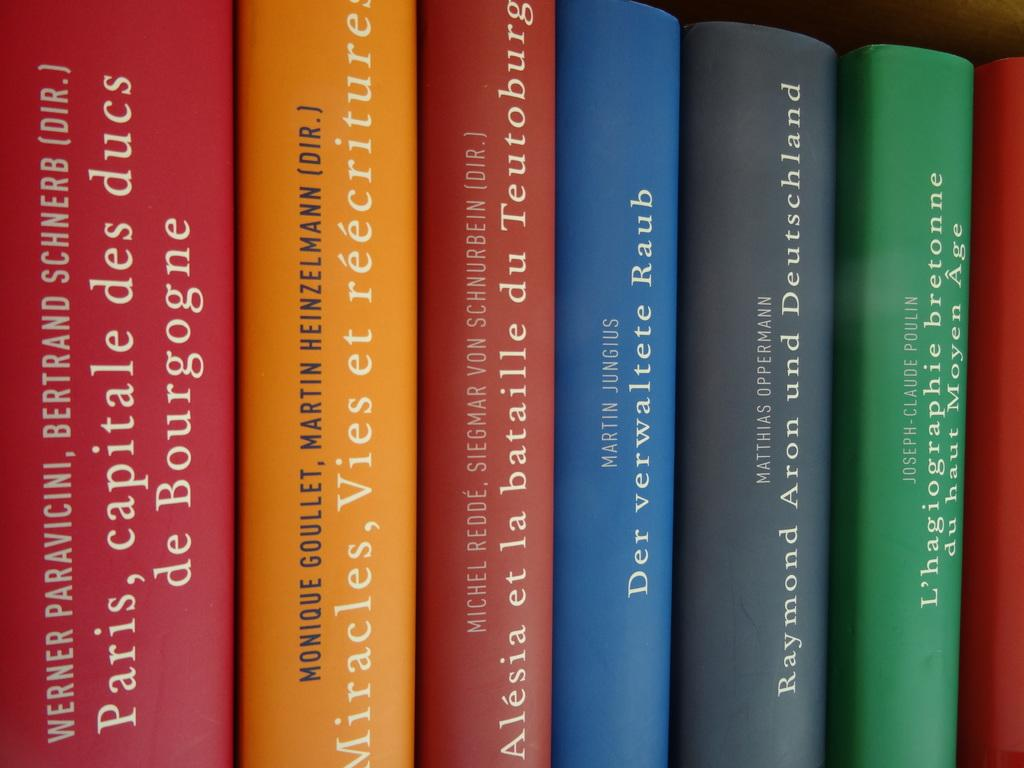<image>
Describe the image concisely. A series of books including Der verwaltete Raub. 